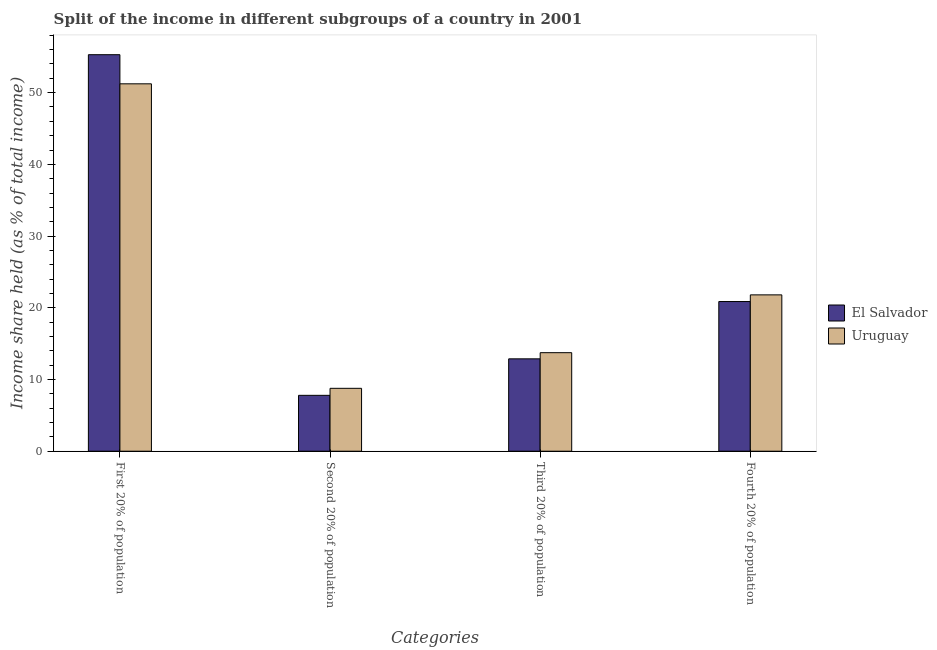How many different coloured bars are there?
Ensure brevity in your answer.  2. How many groups of bars are there?
Offer a very short reply. 4. Are the number of bars on each tick of the X-axis equal?
Provide a succinct answer. Yes. How many bars are there on the 3rd tick from the right?
Offer a terse response. 2. What is the label of the 2nd group of bars from the left?
Offer a terse response. Second 20% of population. What is the share of the income held by fourth 20% of the population in El Salvador?
Provide a short and direct response. 20.87. Across all countries, what is the maximum share of the income held by fourth 20% of the population?
Provide a succinct answer. 21.8. Across all countries, what is the minimum share of the income held by first 20% of the population?
Give a very brief answer. 51.23. In which country was the share of the income held by fourth 20% of the population maximum?
Offer a terse response. Uruguay. In which country was the share of the income held by second 20% of the population minimum?
Provide a succinct answer. El Salvador. What is the total share of the income held by fourth 20% of the population in the graph?
Your response must be concise. 42.67. What is the difference between the share of the income held by fourth 20% of the population in El Salvador and that in Uruguay?
Provide a short and direct response. -0.93. What is the difference between the share of the income held by first 20% of the population in El Salvador and the share of the income held by fourth 20% of the population in Uruguay?
Keep it short and to the point. 33.49. What is the average share of the income held by fourth 20% of the population per country?
Give a very brief answer. 21.34. What is the difference between the share of the income held by third 20% of the population and share of the income held by second 20% of the population in Uruguay?
Give a very brief answer. 4.97. In how many countries, is the share of the income held by first 20% of the population greater than 26 %?
Offer a terse response. 2. What is the ratio of the share of the income held by second 20% of the population in Uruguay to that in El Salvador?
Offer a very short reply. 1.13. What is the difference between the highest and the second highest share of the income held by first 20% of the population?
Your answer should be compact. 4.06. What is the difference between the highest and the lowest share of the income held by first 20% of the population?
Keep it short and to the point. 4.06. In how many countries, is the share of the income held by first 20% of the population greater than the average share of the income held by first 20% of the population taken over all countries?
Provide a short and direct response. 1. Is the sum of the share of the income held by fourth 20% of the population in El Salvador and Uruguay greater than the maximum share of the income held by first 20% of the population across all countries?
Make the answer very short. No. Is it the case that in every country, the sum of the share of the income held by first 20% of the population and share of the income held by second 20% of the population is greater than the sum of share of the income held by fourth 20% of the population and share of the income held by third 20% of the population?
Give a very brief answer. No. What does the 1st bar from the left in First 20% of population represents?
Provide a succinct answer. El Salvador. What does the 2nd bar from the right in Second 20% of population represents?
Provide a short and direct response. El Salvador. Are all the bars in the graph horizontal?
Offer a very short reply. No. What is the difference between two consecutive major ticks on the Y-axis?
Keep it short and to the point. 10. Are the values on the major ticks of Y-axis written in scientific E-notation?
Ensure brevity in your answer.  No. Does the graph contain any zero values?
Keep it short and to the point. No. Where does the legend appear in the graph?
Make the answer very short. Center right. How many legend labels are there?
Keep it short and to the point. 2. What is the title of the graph?
Offer a very short reply. Split of the income in different subgroups of a country in 2001. What is the label or title of the X-axis?
Ensure brevity in your answer.  Categories. What is the label or title of the Y-axis?
Keep it short and to the point. Income share held (as % of total income). What is the Income share held (as % of total income) of El Salvador in First 20% of population?
Ensure brevity in your answer.  55.29. What is the Income share held (as % of total income) of Uruguay in First 20% of population?
Your response must be concise. 51.23. What is the Income share held (as % of total income) in El Salvador in Second 20% of population?
Offer a very short reply. 7.79. What is the Income share held (as % of total income) of Uruguay in Second 20% of population?
Ensure brevity in your answer.  8.77. What is the Income share held (as % of total income) of El Salvador in Third 20% of population?
Ensure brevity in your answer.  12.88. What is the Income share held (as % of total income) in Uruguay in Third 20% of population?
Keep it short and to the point. 13.74. What is the Income share held (as % of total income) of El Salvador in Fourth 20% of population?
Keep it short and to the point. 20.87. What is the Income share held (as % of total income) of Uruguay in Fourth 20% of population?
Offer a terse response. 21.8. Across all Categories, what is the maximum Income share held (as % of total income) in El Salvador?
Provide a succinct answer. 55.29. Across all Categories, what is the maximum Income share held (as % of total income) of Uruguay?
Your answer should be very brief. 51.23. Across all Categories, what is the minimum Income share held (as % of total income) in El Salvador?
Ensure brevity in your answer.  7.79. Across all Categories, what is the minimum Income share held (as % of total income) of Uruguay?
Provide a short and direct response. 8.77. What is the total Income share held (as % of total income) in El Salvador in the graph?
Make the answer very short. 96.83. What is the total Income share held (as % of total income) in Uruguay in the graph?
Give a very brief answer. 95.54. What is the difference between the Income share held (as % of total income) in El Salvador in First 20% of population and that in Second 20% of population?
Provide a short and direct response. 47.5. What is the difference between the Income share held (as % of total income) of Uruguay in First 20% of population and that in Second 20% of population?
Make the answer very short. 42.46. What is the difference between the Income share held (as % of total income) of El Salvador in First 20% of population and that in Third 20% of population?
Your answer should be compact. 42.41. What is the difference between the Income share held (as % of total income) in Uruguay in First 20% of population and that in Third 20% of population?
Your response must be concise. 37.49. What is the difference between the Income share held (as % of total income) of El Salvador in First 20% of population and that in Fourth 20% of population?
Provide a succinct answer. 34.42. What is the difference between the Income share held (as % of total income) of Uruguay in First 20% of population and that in Fourth 20% of population?
Provide a succinct answer. 29.43. What is the difference between the Income share held (as % of total income) in El Salvador in Second 20% of population and that in Third 20% of population?
Provide a short and direct response. -5.09. What is the difference between the Income share held (as % of total income) in Uruguay in Second 20% of population and that in Third 20% of population?
Give a very brief answer. -4.97. What is the difference between the Income share held (as % of total income) in El Salvador in Second 20% of population and that in Fourth 20% of population?
Provide a succinct answer. -13.08. What is the difference between the Income share held (as % of total income) of Uruguay in Second 20% of population and that in Fourth 20% of population?
Keep it short and to the point. -13.03. What is the difference between the Income share held (as % of total income) in El Salvador in Third 20% of population and that in Fourth 20% of population?
Keep it short and to the point. -7.99. What is the difference between the Income share held (as % of total income) of Uruguay in Third 20% of population and that in Fourth 20% of population?
Your answer should be very brief. -8.06. What is the difference between the Income share held (as % of total income) in El Salvador in First 20% of population and the Income share held (as % of total income) in Uruguay in Second 20% of population?
Offer a very short reply. 46.52. What is the difference between the Income share held (as % of total income) in El Salvador in First 20% of population and the Income share held (as % of total income) in Uruguay in Third 20% of population?
Provide a succinct answer. 41.55. What is the difference between the Income share held (as % of total income) in El Salvador in First 20% of population and the Income share held (as % of total income) in Uruguay in Fourth 20% of population?
Your answer should be compact. 33.49. What is the difference between the Income share held (as % of total income) in El Salvador in Second 20% of population and the Income share held (as % of total income) in Uruguay in Third 20% of population?
Your response must be concise. -5.95. What is the difference between the Income share held (as % of total income) in El Salvador in Second 20% of population and the Income share held (as % of total income) in Uruguay in Fourth 20% of population?
Provide a succinct answer. -14.01. What is the difference between the Income share held (as % of total income) in El Salvador in Third 20% of population and the Income share held (as % of total income) in Uruguay in Fourth 20% of population?
Keep it short and to the point. -8.92. What is the average Income share held (as % of total income) in El Salvador per Categories?
Your answer should be compact. 24.21. What is the average Income share held (as % of total income) in Uruguay per Categories?
Your response must be concise. 23.89. What is the difference between the Income share held (as % of total income) of El Salvador and Income share held (as % of total income) of Uruguay in First 20% of population?
Ensure brevity in your answer.  4.06. What is the difference between the Income share held (as % of total income) of El Salvador and Income share held (as % of total income) of Uruguay in Second 20% of population?
Your answer should be compact. -0.98. What is the difference between the Income share held (as % of total income) of El Salvador and Income share held (as % of total income) of Uruguay in Third 20% of population?
Provide a succinct answer. -0.86. What is the difference between the Income share held (as % of total income) in El Salvador and Income share held (as % of total income) in Uruguay in Fourth 20% of population?
Ensure brevity in your answer.  -0.93. What is the ratio of the Income share held (as % of total income) of El Salvador in First 20% of population to that in Second 20% of population?
Ensure brevity in your answer.  7.1. What is the ratio of the Income share held (as % of total income) of Uruguay in First 20% of population to that in Second 20% of population?
Ensure brevity in your answer.  5.84. What is the ratio of the Income share held (as % of total income) in El Salvador in First 20% of population to that in Third 20% of population?
Your answer should be compact. 4.29. What is the ratio of the Income share held (as % of total income) in Uruguay in First 20% of population to that in Third 20% of population?
Offer a terse response. 3.73. What is the ratio of the Income share held (as % of total income) in El Salvador in First 20% of population to that in Fourth 20% of population?
Give a very brief answer. 2.65. What is the ratio of the Income share held (as % of total income) of Uruguay in First 20% of population to that in Fourth 20% of population?
Provide a succinct answer. 2.35. What is the ratio of the Income share held (as % of total income) in El Salvador in Second 20% of population to that in Third 20% of population?
Provide a succinct answer. 0.6. What is the ratio of the Income share held (as % of total income) in Uruguay in Second 20% of population to that in Third 20% of population?
Provide a short and direct response. 0.64. What is the ratio of the Income share held (as % of total income) of El Salvador in Second 20% of population to that in Fourth 20% of population?
Offer a terse response. 0.37. What is the ratio of the Income share held (as % of total income) in Uruguay in Second 20% of population to that in Fourth 20% of population?
Offer a very short reply. 0.4. What is the ratio of the Income share held (as % of total income) of El Salvador in Third 20% of population to that in Fourth 20% of population?
Provide a succinct answer. 0.62. What is the ratio of the Income share held (as % of total income) in Uruguay in Third 20% of population to that in Fourth 20% of population?
Your answer should be compact. 0.63. What is the difference between the highest and the second highest Income share held (as % of total income) of El Salvador?
Offer a terse response. 34.42. What is the difference between the highest and the second highest Income share held (as % of total income) in Uruguay?
Give a very brief answer. 29.43. What is the difference between the highest and the lowest Income share held (as % of total income) of El Salvador?
Your answer should be very brief. 47.5. What is the difference between the highest and the lowest Income share held (as % of total income) in Uruguay?
Offer a terse response. 42.46. 